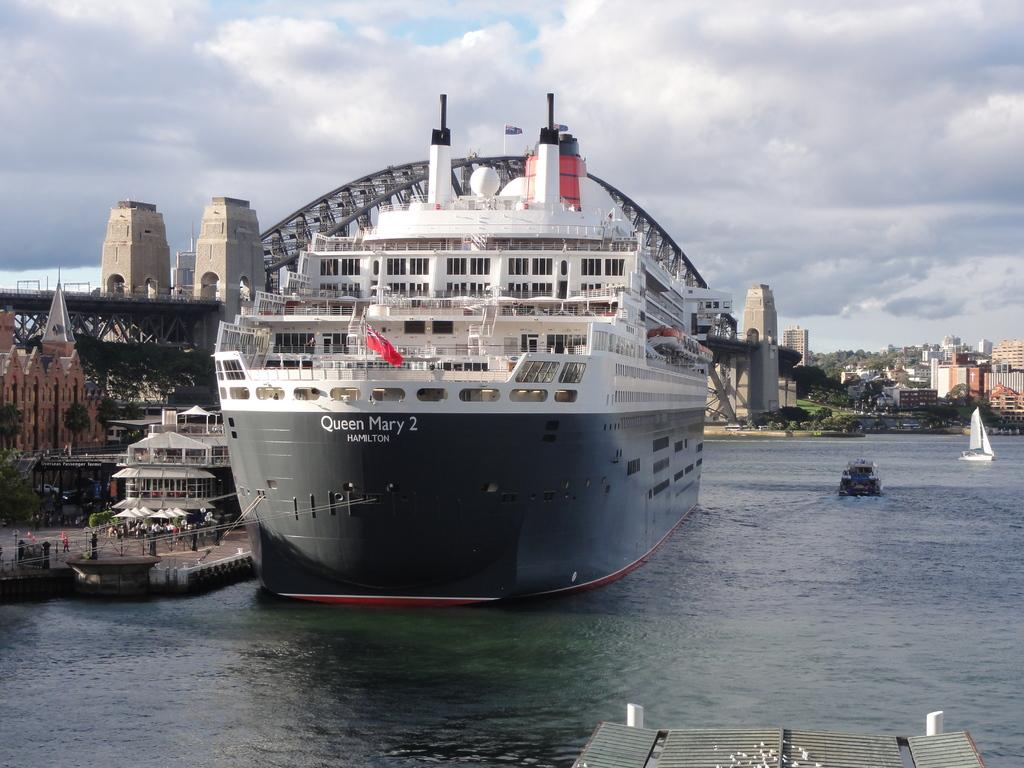What can be seen at the bottom of the image? There are ships at the bottom of the image. What type of natural vegetation is visible in the image? There are trees visible in the image. What type of man-made structures can be seen in the image? There are buildings in the image. What connects the two sides of the image? There is a bridge in the image. What is visible at the top of the image? There are clouds and the sky visible at the top of the image. What type of mint is growing on the bridge in the image? There is no mint present in the image; it features ships, trees, buildings, a bridge, clouds, and the sky. What songs can be heard playing from the light in the image? There is no light or music present in the image; it only shows ships, trees, buildings, a bridge, clouds, and the sky. 